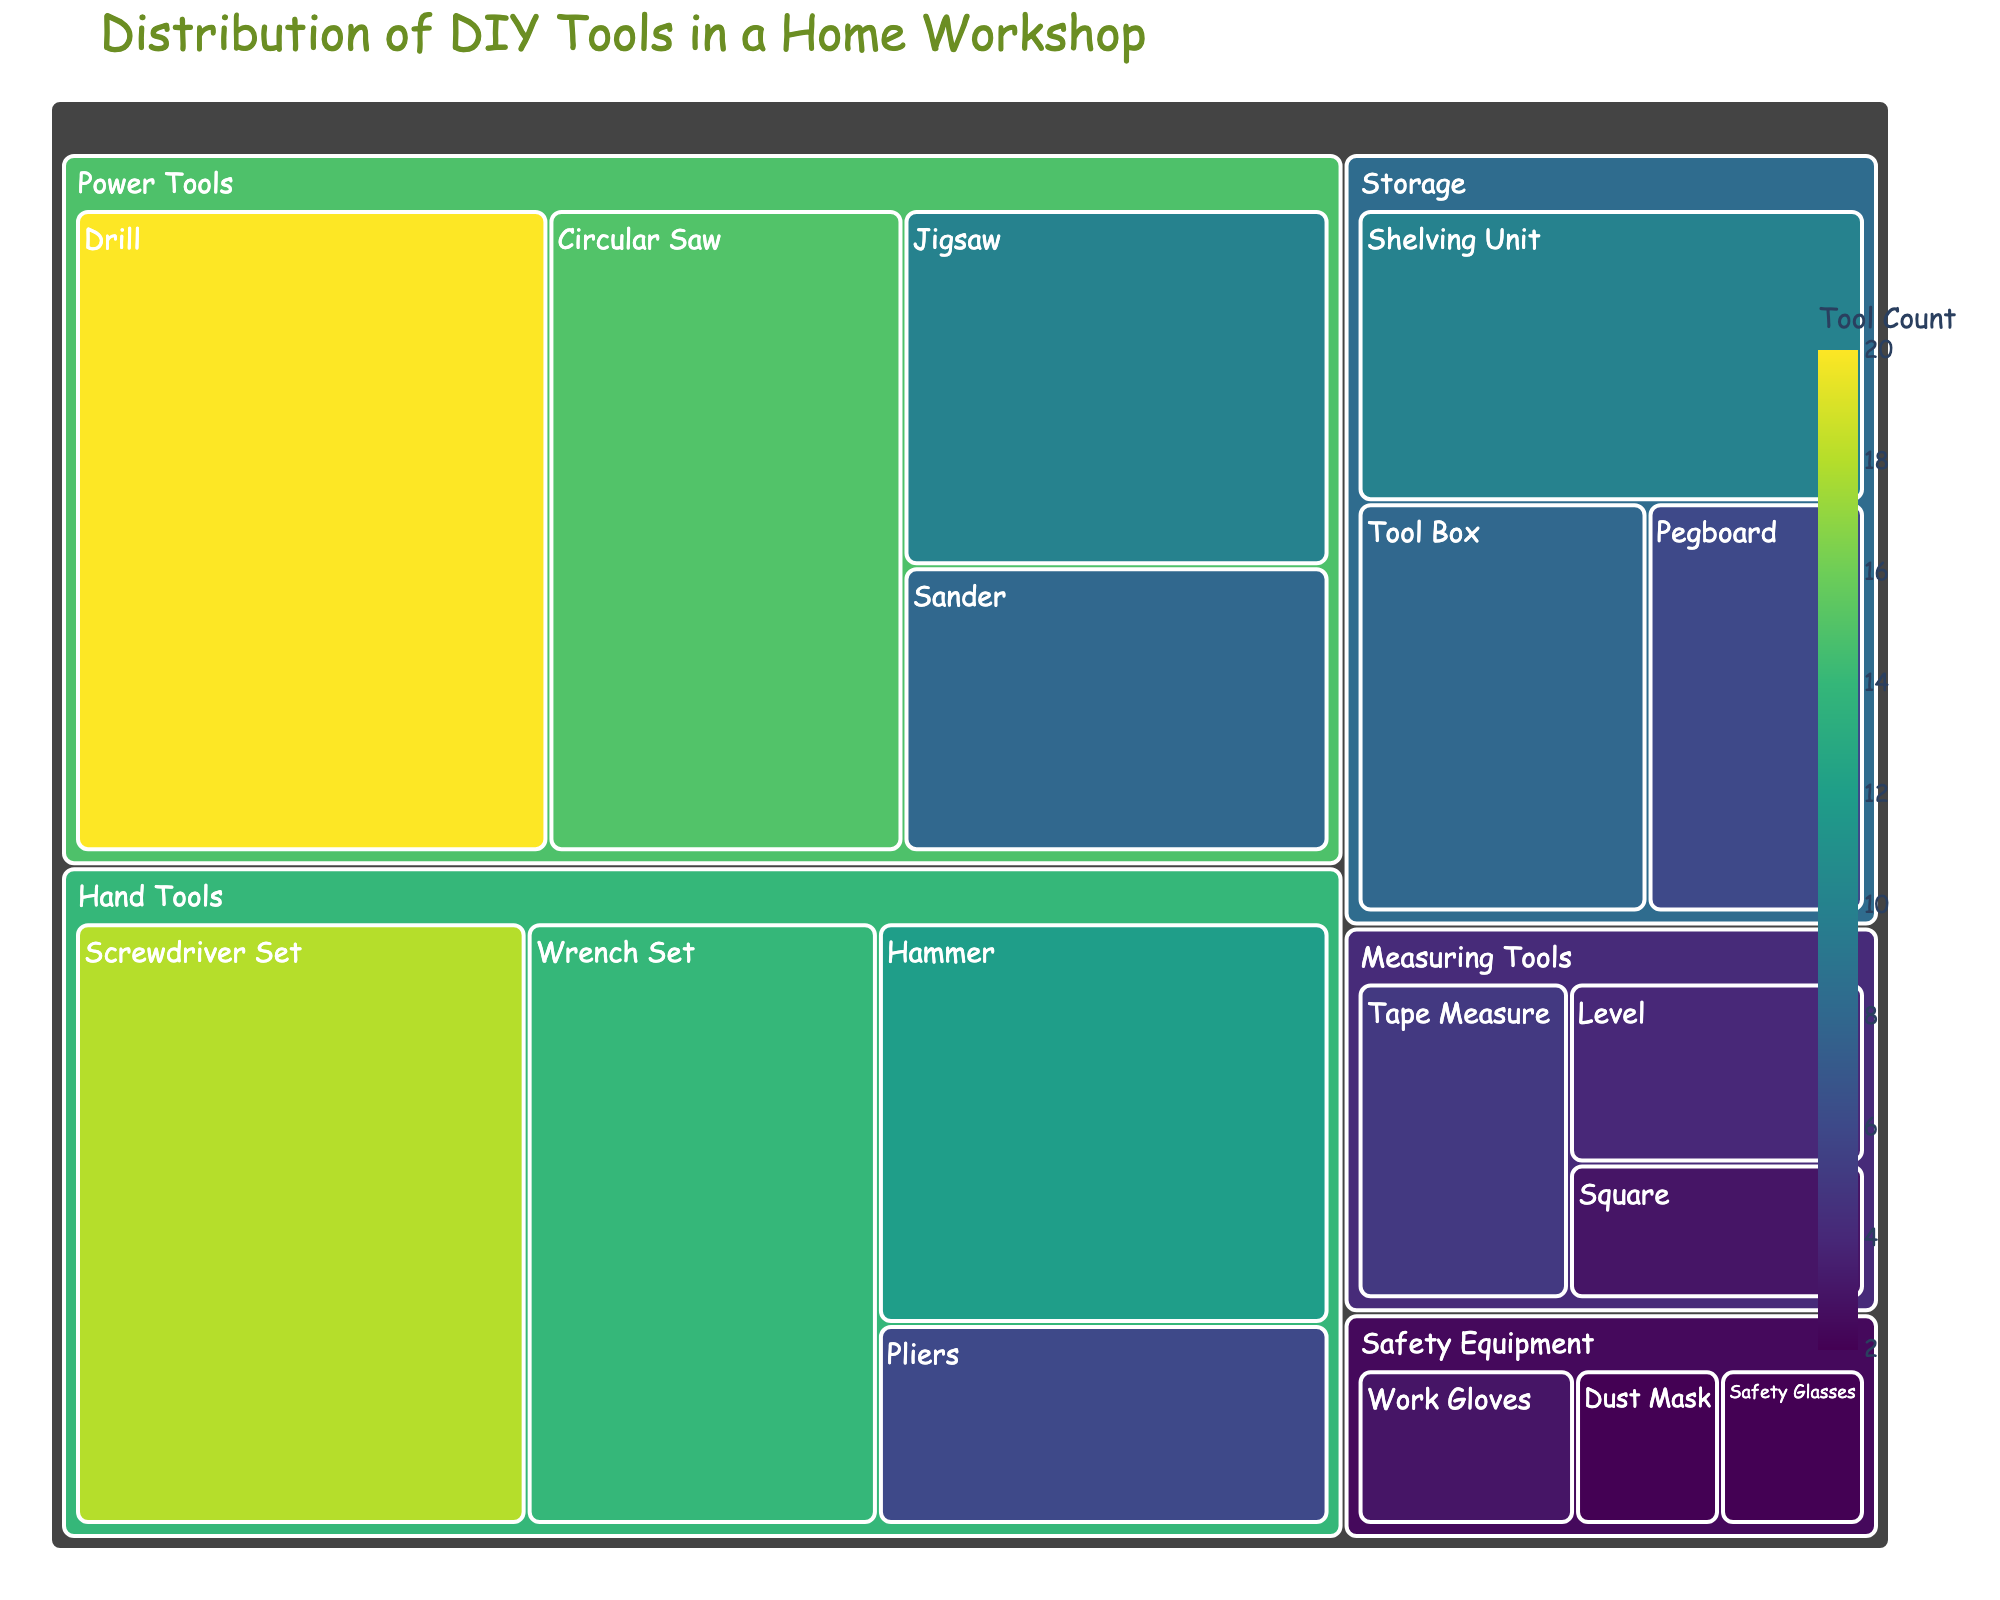Which category has the highest number of tools? To determine the category with the highest number of tools, we should add up the values for each subcategory within each category. Power Tools: 20 + 15 + 10 + 8 = 53; Hand Tools: 12 + 18 + 6 + 14 = 50; Measuring Tools: 5 + 4 + 3 = 12; Safety Equipment: 2 + 3 + 2 = 7; Storage: 8 + 6 + 10 = 24. The highest total is for Power Tools (53).
Answer: Power Tools What is the title of the figure? The title of the figure is located prominently at the top and provides a summary of the content.
Answer: Distribution of DIY Tools in a Home Workshop Which subcategory under Hand Tools has the fewest tools? Under the Hand Tools category, we compare the values for each subcategory: Hammer (12), Screwdriver Set (18), Pliers (6), Wrench Set (14). Pliers have the fewest tools.
Answer: Pliers How many more tools are there in the Power Tools category compared to Safety Equipment? First, calculate the total number of tools in each category: Power Tools (53), Safety Equipment (7). The difference is 53 - 7 = 46 tools.
Answer: 46 Which subcategory has the smallest count across all categories? By identifying the smallest value in the entire dataset, we find Safety Glasses and Dust Mask under Safety Equipment both have the smallest count with a value of 2.
Answer: Safety Glasses and Dust Mask Compare the number of tools in the Storage category to the Measuring Tools category. Which one has more tools? Calculate the total for both categories: Storage (8 + 6 + 10 = 24), Measuring Tools (5 + 4 + 3 = 12). Storage has more tools.
Answer: Storage How is the color of the treemap related to the data? The figure uses a color scale to represent the values of tool counts, darker shades indicate higher values while lighter shades indicate lower values.
Answer: Darker colors signify higher tool counts, lighter colors signify lower tool counts What is the combined count for all Hand Tools and Measuring Tools? Sum the total of Hand Tools (50) and Measuring Tools (12). The combined count is 50 + 12 = 62 tools.
Answer: 62 What is the largest subcategory in the Power Tools category? Within Power Tools, compare values: Drill (20), Circular Saw (15), Jigsaw (10), Sander (8). Drill has the largest count.
Answer: Drill 